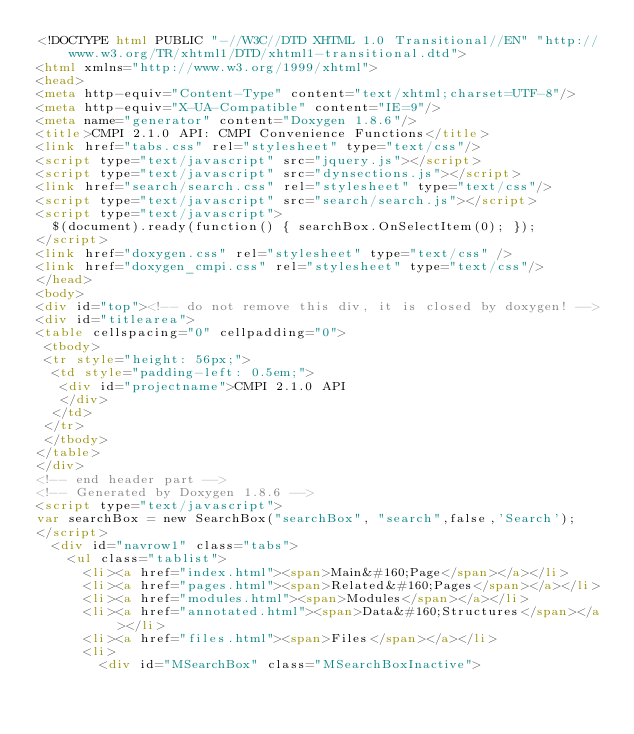Convert code to text. <code><loc_0><loc_0><loc_500><loc_500><_HTML_><!DOCTYPE html PUBLIC "-//W3C//DTD XHTML 1.0 Transitional//EN" "http://www.w3.org/TR/xhtml1/DTD/xhtml1-transitional.dtd">
<html xmlns="http://www.w3.org/1999/xhtml">
<head>
<meta http-equiv="Content-Type" content="text/xhtml;charset=UTF-8"/>
<meta http-equiv="X-UA-Compatible" content="IE=9"/>
<meta name="generator" content="Doxygen 1.8.6"/>
<title>CMPI 2.1.0 API: CMPI Convenience Functions</title>
<link href="tabs.css" rel="stylesheet" type="text/css"/>
<script type="text/javascript" src="jquery.js"></script>
<script type="text/javascript" src="dynsections.js"></script>
<link href="search/search.css" rel="stylesheet" type="text/css"/>
<script type="text/javascript" src="search/search.js"></script>
<script type="text/javascript">
  $(document).ready(function() { searchBox.OnSelectItem(0); });
</script>
<link href="doxygen.css" rel="stylesheet" type="text/css" />
<link href="doxygen_cmpi.css" rel="stylesheet" type="text/css"/>
</head>
<body>
<div id="top"><!-- do not remove this div, it is closed by doxygen! -->
<div id="titlearea">
<table cellspacing="0" cellpadding="0">
 <tbody>
 <tr style="height: 56px;">
  <td style="padding-left: 0.5em;">
   <div id="projectname">CMPI 2.1.0 API
   </div>
  </td>
 </tr>
 </tbody>
</table>
</div>
<!-- end header part -->
<!-- Generated by Doxygen 1.8.6 -->
<script type="text/javascript">
var searchBox = new SearchBox("searchBox", "search",false,'Search');
</script>
  <div id="navrow1" class="tabs">
    <ul class="tablist">
      <li><a href="index.html"><span>Main&#160;Page</span></a></li>
      <li><a href="pages.html"><span>Related&#160;Pages</span></a></li>
      <li><a href="modules.html"><span>Modules</span></a></li>
      <li><a href="annotated.html"><span>Data&#160;Structures</span></a></li>
      <li><a href="files.html"><span>Files</span></a></li>
      <li>
        <div id="MSearchBox" class="MSearchBoxInactive"></code> 